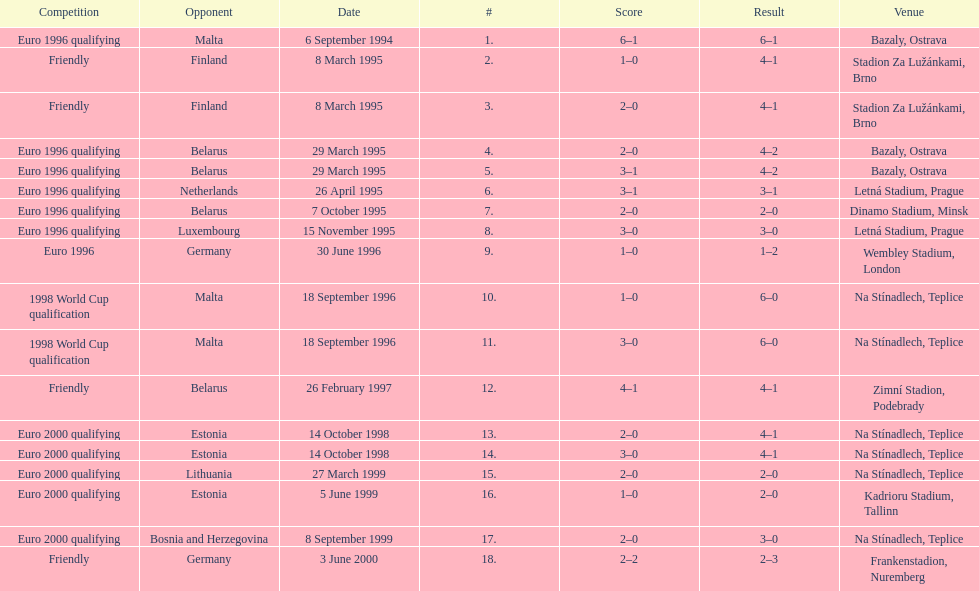How many euro 2000 qualifying competitions are listed? 4. 